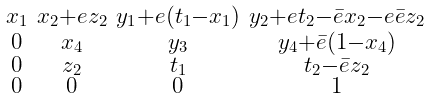Convert formula to latex. <formula><loc_0><loc_0><loc_500><loc_500>\begin{smallmatrix} x _ { 1 } & x _ { 2 } + e z _ { 2 } & y _ { 1 } + e ( t _ { 1 } - x _ { 1 } ) & y _ { 2 } + e t _ { 2 } - \bar { e } x _ { 2 } - e \bar { e } z _ { 2 } \\ 0 & x _ { 4 } & y _ { 3 } & y _ { 4 } + \bar { e } ( 1 - x _ { 4 } ) \\ 0 & z _ { 2 } & t _ { 1 } & t _ { 2 } - \bar { e } z _ { 2 } \\ 0 & 0 & 0 & 1 \end{smallmatrix}</formula> 